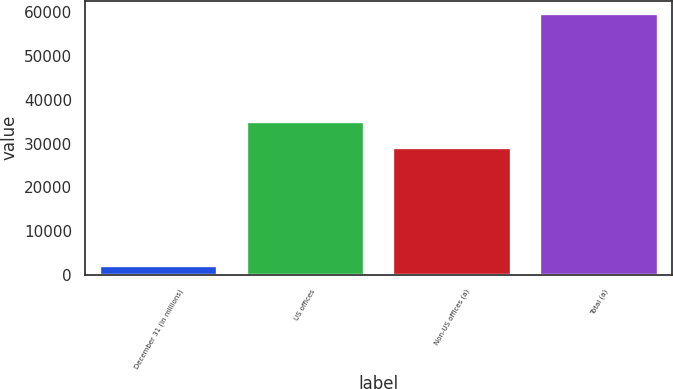<chart> <loc_0><loc_0><loc_500><loc_500><bar_chart><fcel>December 31 (in millions)<fcel>US offices<fcel>Non-US offices (a)<fcel>Total (a)<nl><fcel>2017<fcel>34819.3<fcel>29049<fcel>59720<nl></chart> 